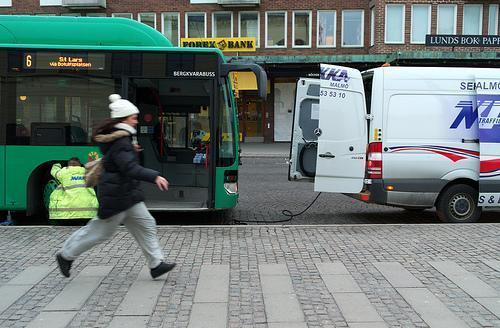How many people are in the picture?
Give a very brief answer. 2. 